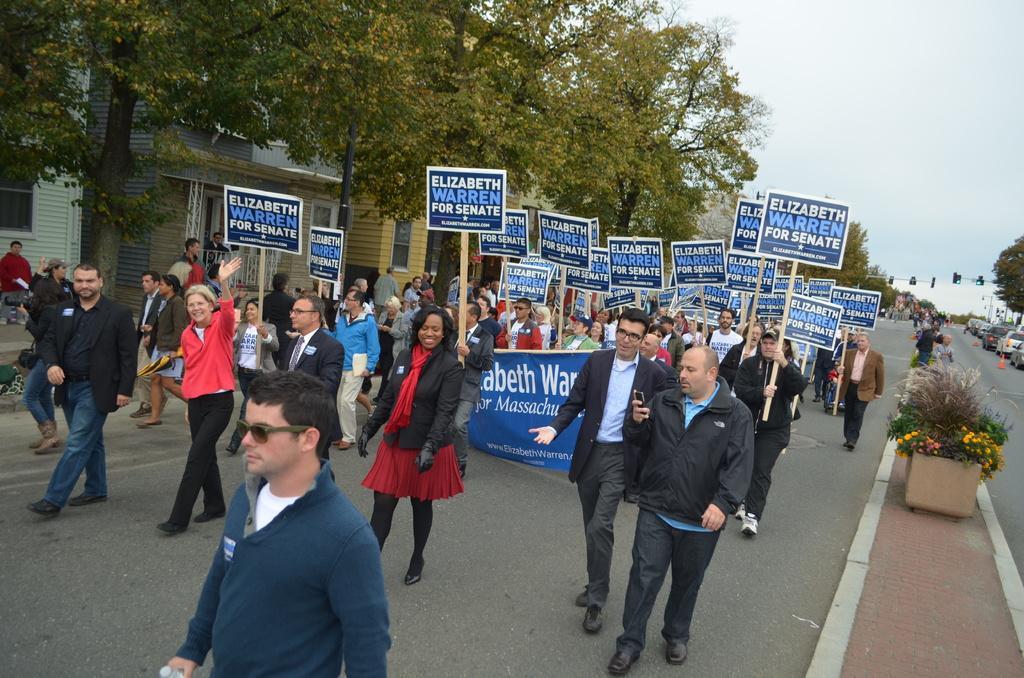Please provide a concise description of this image. In the image I can see some people who are holding some boards and banner and also I can see some trees, vehicles, buildings. 